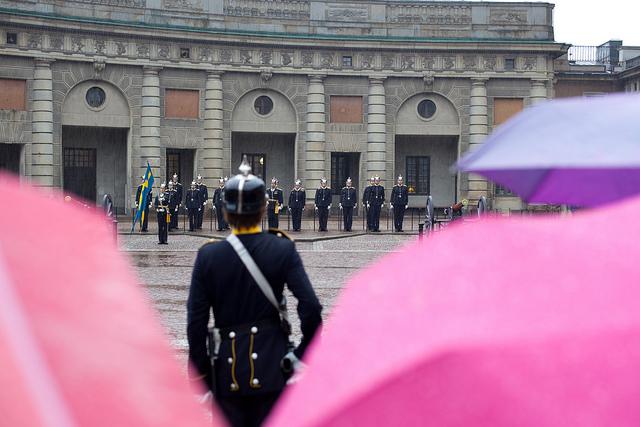Is there security in the photo?
Be succinct. Yes. Is it day or night?
Write a very short answer. Day. What colors are the umbrellas?
Quick response, please. Pink and purple. 